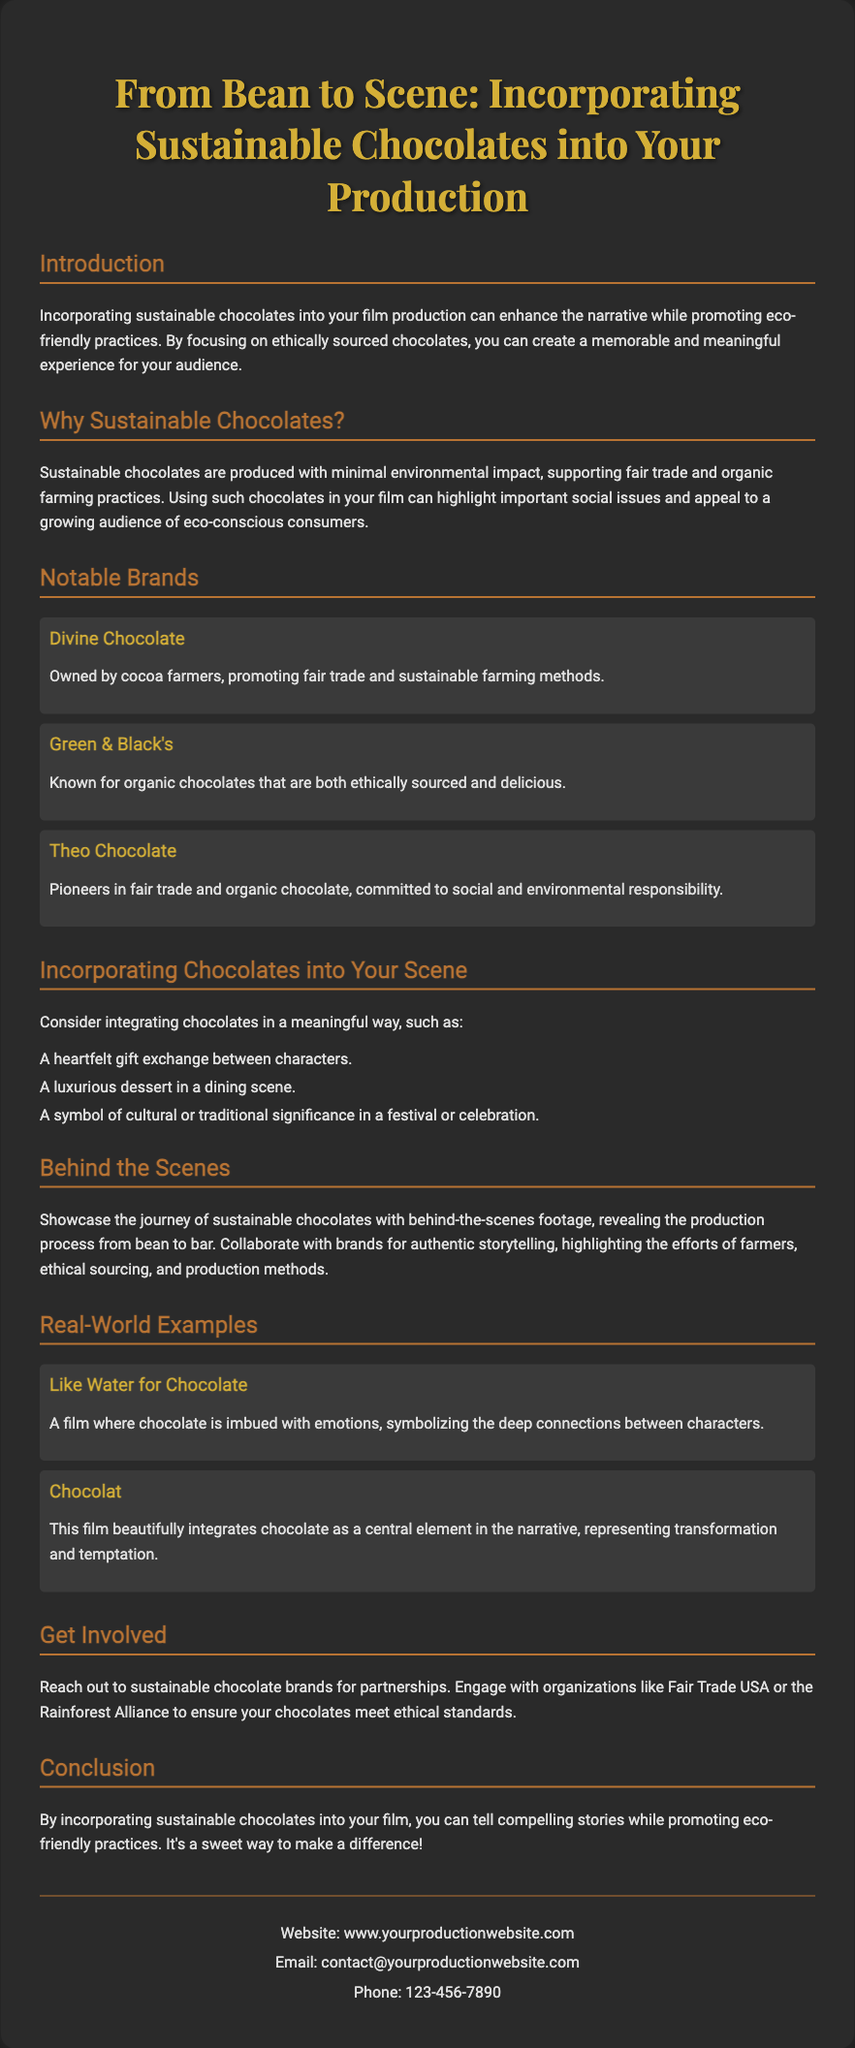What is the title of the flyer? The title of the flyer is prominently displayed at the top of the document, which is "From Bean to Scene: Incorporating Sustainable Chocolates into Your Production."
Answer: From Bean to Scene: Incorporating Sustainable Chocolates into Your Production What are the three notable chocolate brands mentioned? The document lists three brands under the "Notable Brands" section, which are Divine Chocolate, Green & Black's, and Theo Chocolate.
Answer: Divine Chocolate, Green & Black's, Theo Chocolate What is one way to incorporate chocolates into a scene? The document provides several suggestions on integrating chocolates, one of which includes "A heartfelt gift exchange between characters."
Answer: A heartfelt gift exchange between characters Which film uses chocolate to symbolize deep connections? The document gives an example of a film in the "Real-World Examples" section, which indicates that "Like Water for Chocolate" uses chocolate to symbolize emotional connections.
Answer: Like Water for Chocolate What is suggested for showcasing sustainable chocolates? The document suggests showcasing the production process from bean to bar as part of the "Behind the Scenes" section.
Answer: Show the journey of sustainable chocolates What is a key benefit of using sustainable chocolates in film? The flyer explains that using sustainable chocolates can enhance the narrative while promoting eco-friendly practices, making it a significant benefit.
Answer: Enhance the narrative while promoting eco-friendly practices What organization can be contacted for ethical standards? The document mentions "Fair Trade USA" and "the Rainforest Alliance" as organizations to engage with for ensuring ethical standards.
Answer: Fair Trade USA or the Rainforest Alliance How does the document suggest to get involved? The flyer mentions reaching out to sustainable chocolate brands as a way to get involved, which is detailed in the "Get Involved" section.
Answer: Reach out to sustainable chocolate brands 